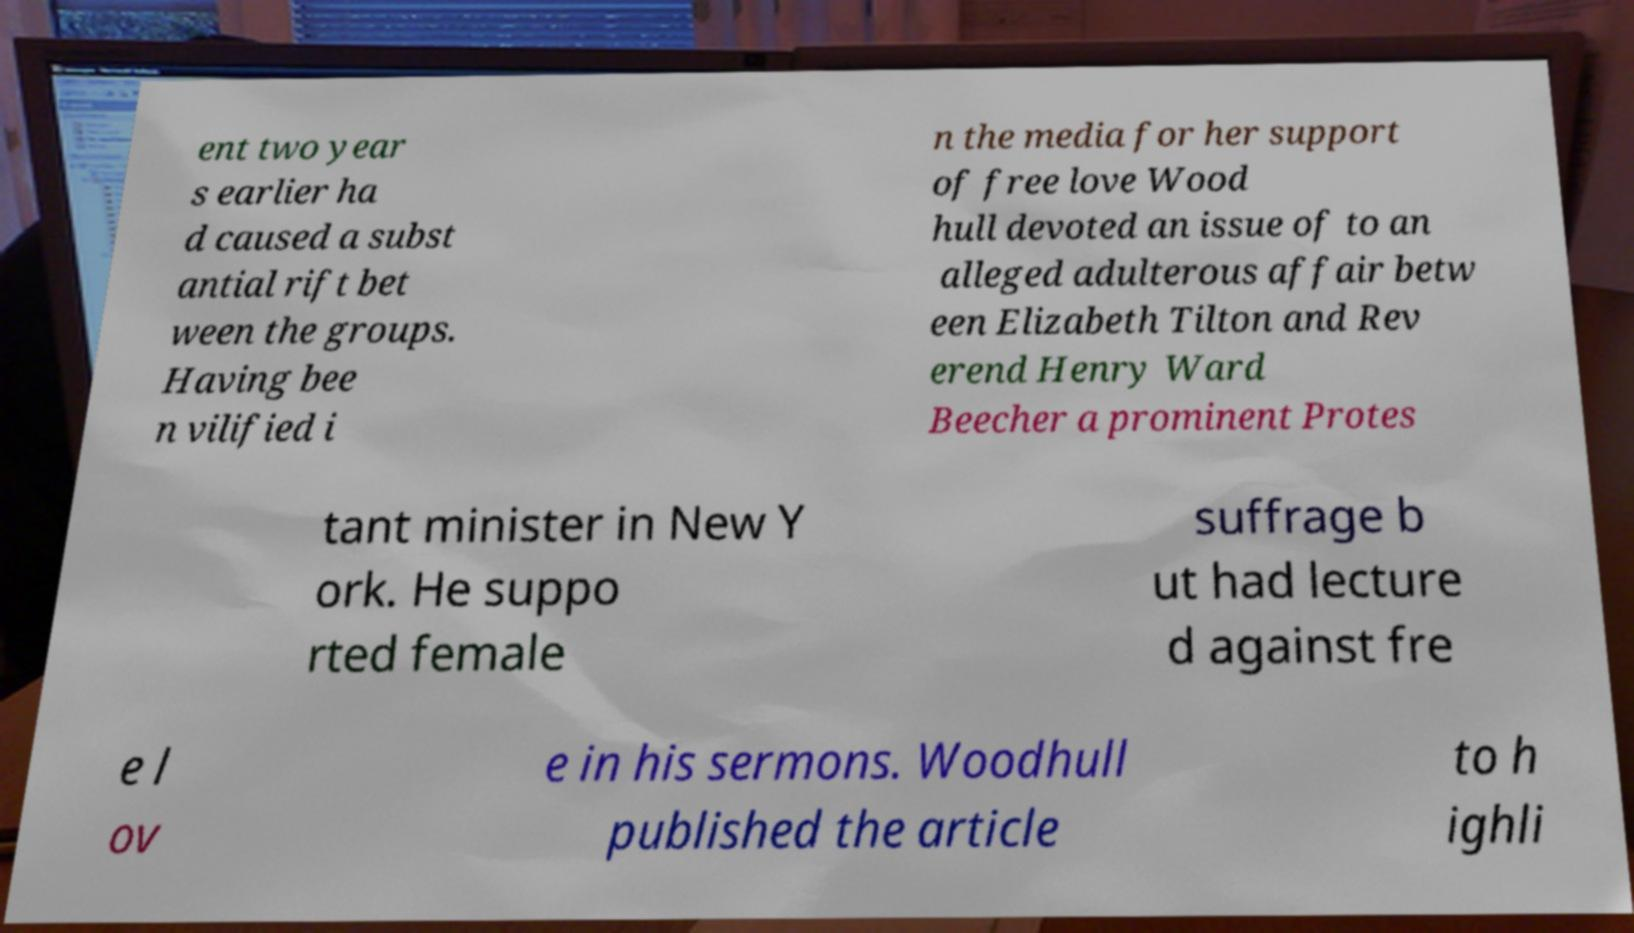Please read and relay the text visible in this image. What does it say? ent two year s earlier ha d caused a subst antial rift bet ween the groups. Having bee n vilified i n the media for her support of free love Wood hull devoted an issue of to an alleged adulterous affair betw een Elizabeth Tilton and Rev erend Henry Ward Beecher a prominent Protes tant minister in New Y ork. He suppo rted female suffrage b ut had lecture d against fre e l ov e in his sermons. Woodhull published the article to h ighli 